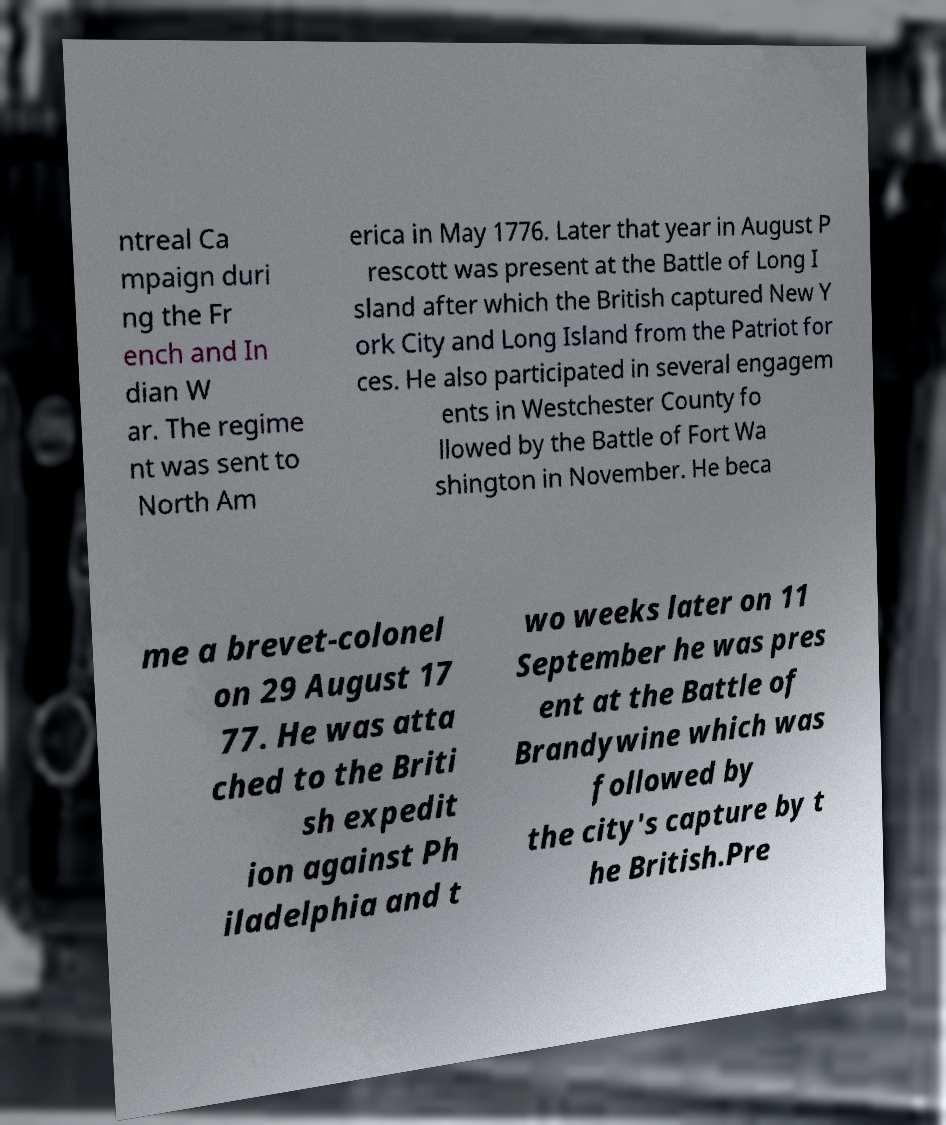Please read and relay the text visible in this image. What does it say? ntreal Ca mpaign duri ng the Fr ench and In dian W ar. The regime nt was sent to North Am erica in May 1776. Later that year in August P rescott was present at the Battle of Long I sland after which the British captured New Y ork City and Long Island from the Patriot for ces. He also participated in several engagem ents in Westchester County fo llowed by the Battle of Fort Wa shington in November. He beca me a brevet-colonel on 29 August 17 77. He was atta ched to the Briti sh expedit ion against Ph iladelphia and t wo weeks later on 11 September he was pres ent at the Battle of Brandywine which was followed by the city's capture by t he British.Pre 